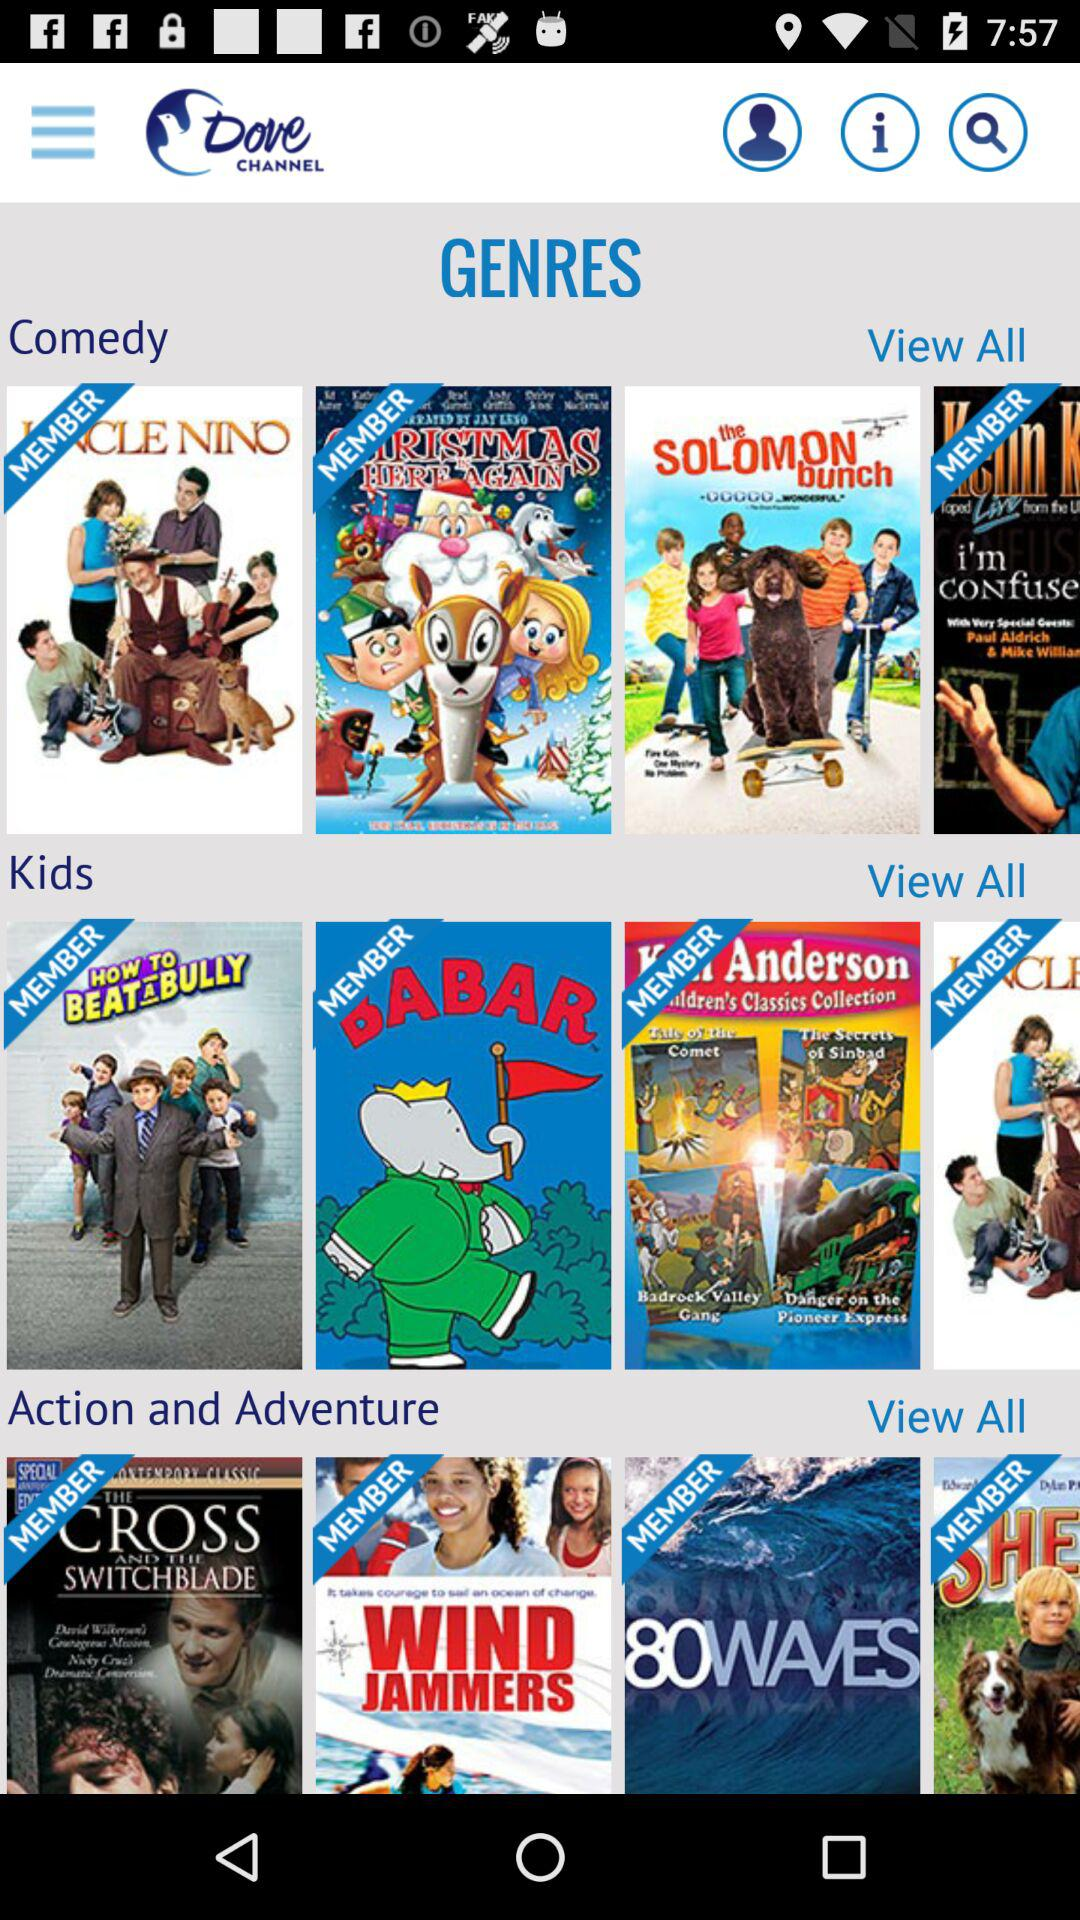What are the names of the movies mentioned in the "Kids" section? The names of the movies are "HOW TO BEAT A BULLY", "BABAR" and "Ken Anderson Children's Classics Collection". 